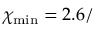<formula> <loc_0><loc_0><loc_500><loc_500>\chi _ { \min } = 2 . 6 /</formula> 